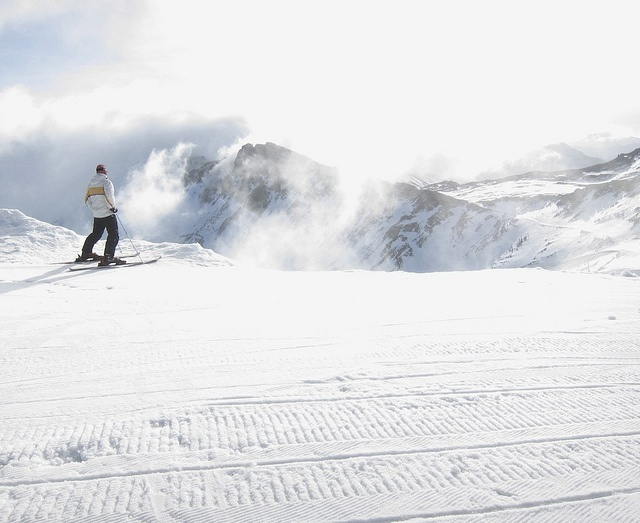Describe the objects in this image and their specific colors. I can see people in lightgray, black, darkgray, and gray tones and skis in lightgray, darkgray, and gray tones in this image. 